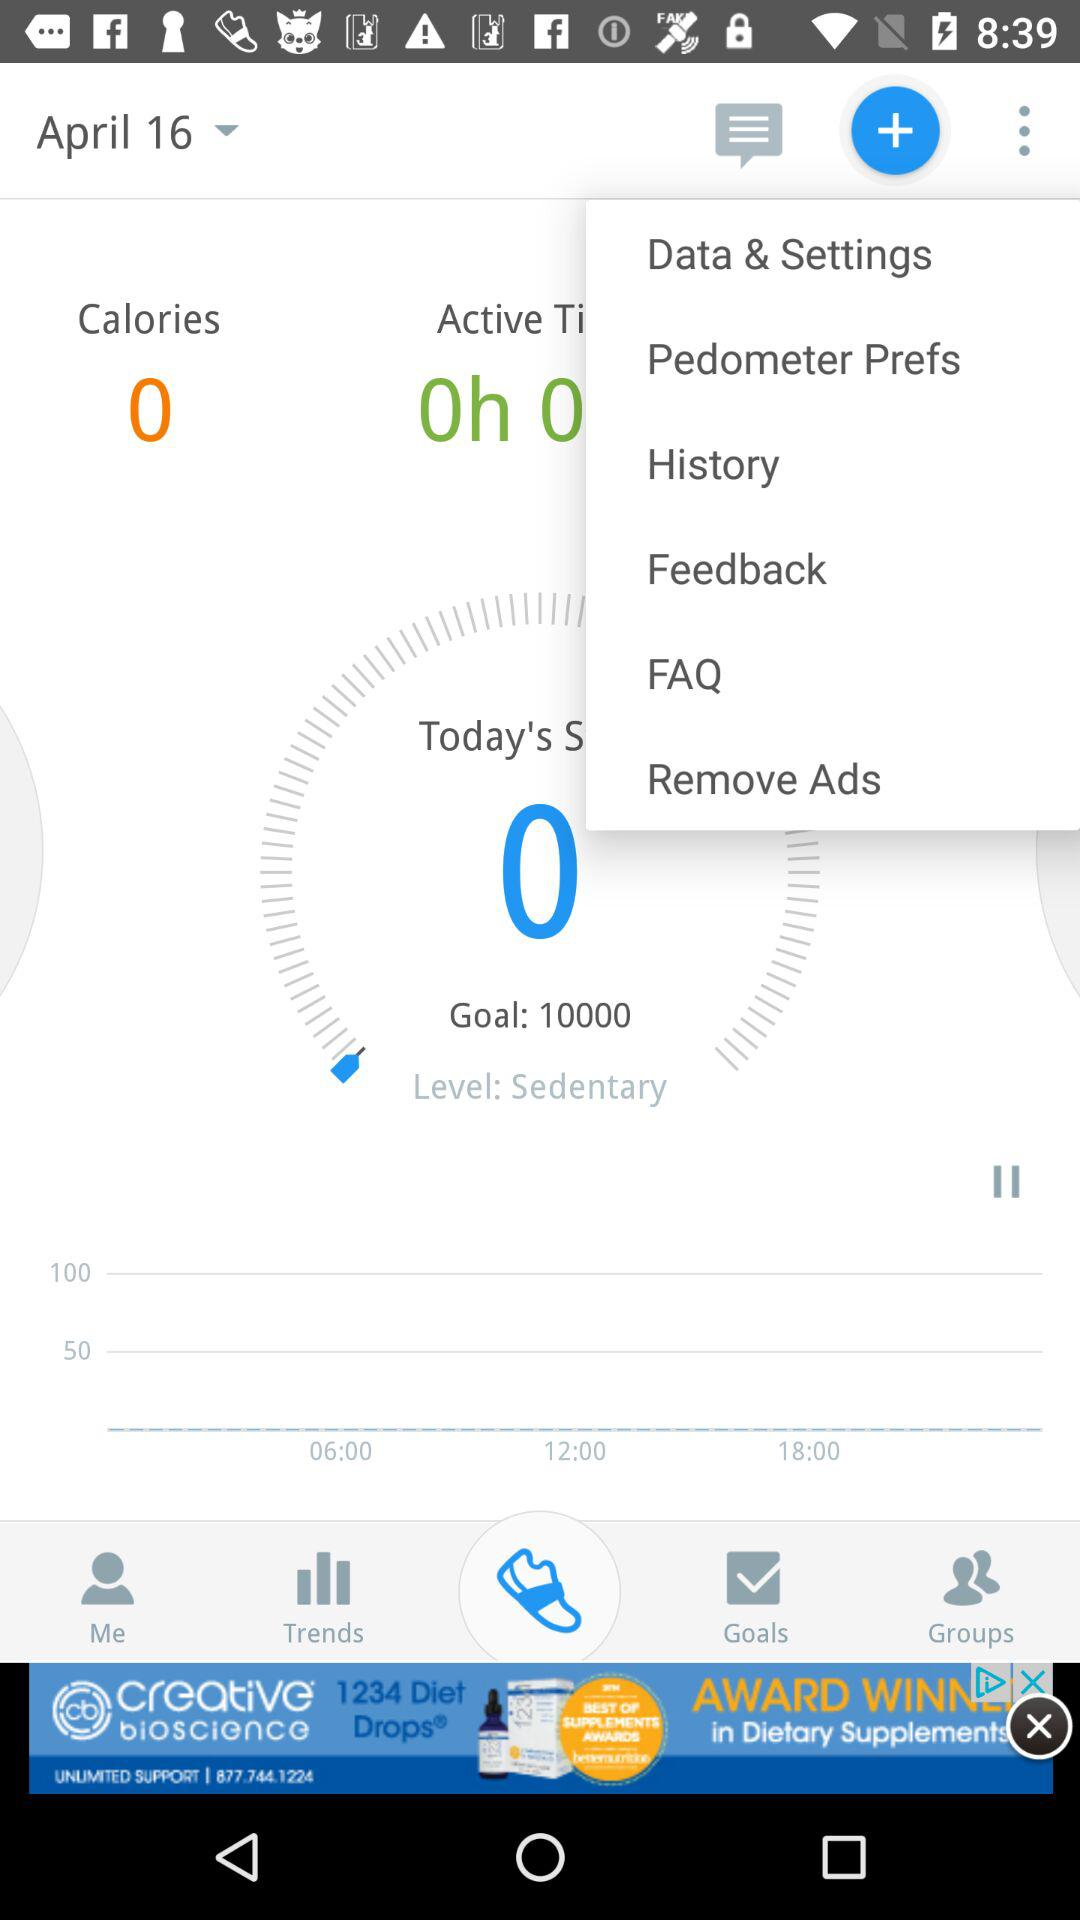What is the time difference between 06:00 and 12:00?
Answer the question using a single word or phrase. 6 hours 